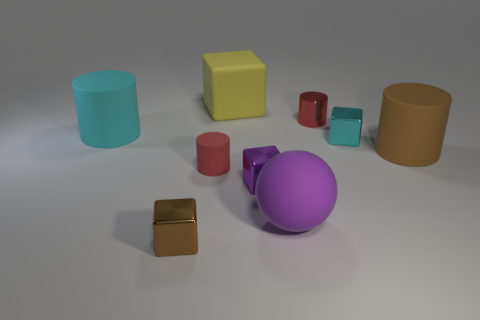Is the number of small red shiny cylinders to the left of the large yellow thing greater than the number of matte things?
Ensure brevity in your answer.  No. Is there any other thing that is the same material as the big cube?
Offer a terse response. Yes. Is the color of the metallic thing to the left of the yellow thing the same as the tiny cylinder to the left of the tiny purple metallic object?
Ensure brevity in your answer.  No. What is the material of the small red thing that is left of the tiny red cylinder that is behind the block that is on the right side of the tiny purple metal object?
Your answer should be compact. Rubber. Is the number of big rubber cylinders greater than the number of large blue cylinders?
Give a very brief answer. Yes. Are there any other things that have the same color as the big sphere?
Provide a short and direct response. Yes. There is a cyan thing that is the same material as the small purple object; what size is it?
Provide a succinct answer. Small. What is the material of the large brown thing?
Make the answer very short. Rubber. What number of brown shiny things are the same size as the purple ball?
Offer a terse response. 0. The tiny matte object that is the same color as the small metallic cylinder is what shape?
Provide a succinct answer. Cylinder. 